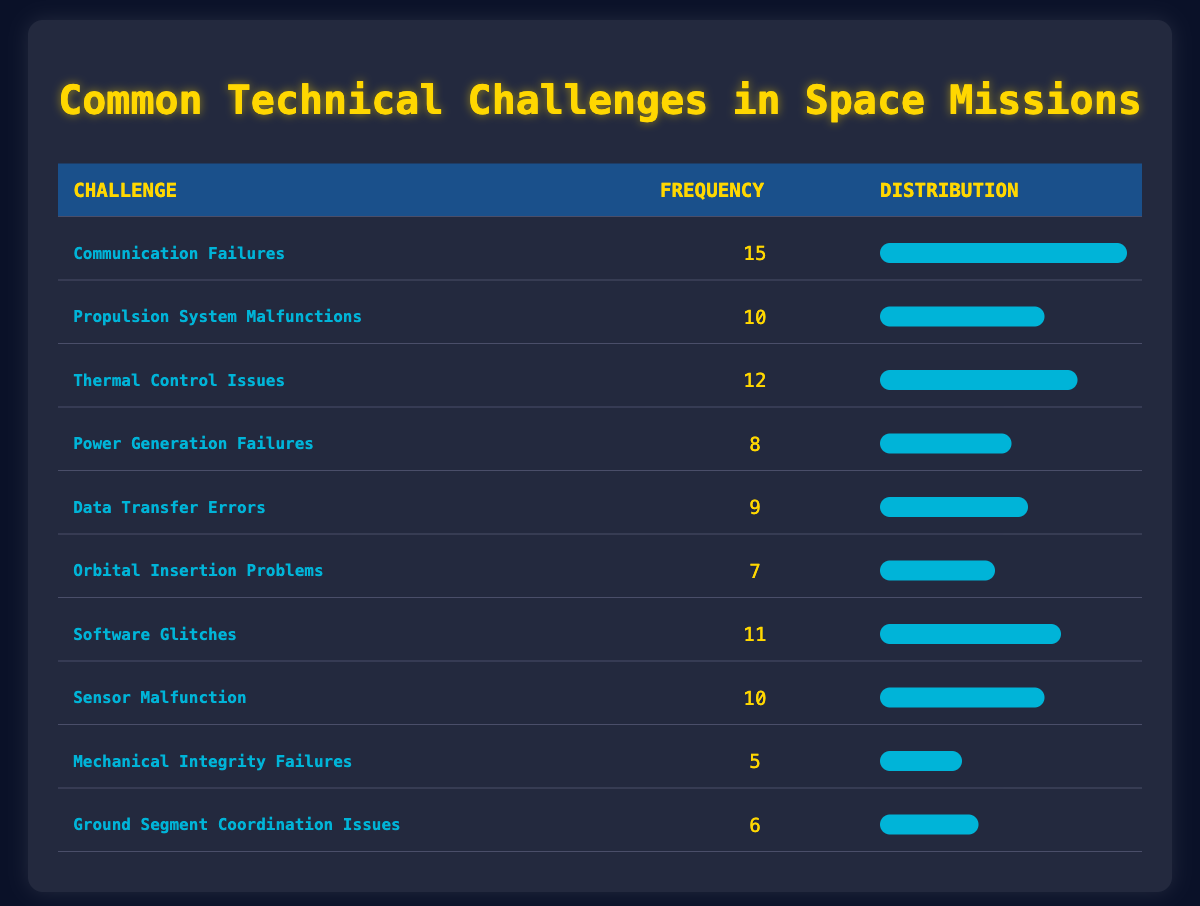What is the most common technical challenge encountered during space missions? The table shows "Communication Failures" with a frequency of 15, which is higher than all other challenges listed.
Answer: Communication Failures How many challenges have a frequency of 10 or more? The challenges with frequencies 10 or more are: Communication Failures (15), Thermal Control Issues (12), Software Glitches (11), and there are two more: Propulsion System Malfunctions and Sensor Malfunction (both with 10). In total, there are 5 challenges.
Answer: 5 Is "Ground Segment Coordination Issues" among the top three most frequent challenges? The frequencies for challenges are: 15 for Communication Failures, 12 for Thermal Control Issues, 11 for Software Glitches, and 10 for both Propulsion Malfunction and Sensor Malfunction. "Ground Segment Coordination Issues" has a frequency of 6, which is not in the top three.
Answer: No What is the total frequency of thermal control issues and propulsion system malfunctions? The frequency of Thermal Control Issues is 12 and that of Propulsion System Malfunctions is 10. Adding these gives 12 + 10 = 22.
Answer: 22 Which challenges have lower frequencies than "Power Generation Failures"? "Power Generation Failures" has a frequency of 8. The challenges lower than 8 are: Orbital Insertion Problems (7), Mechanical Integrity Failures (5), and Ground Segment Coordination Issues (6). Thus, three challenges are lower.
Answer: Orbital Insertion Problems, Mechanical Integrity Failures, Ground Segment Coordination Issues What is the difference in frequency between the most common and the least common challenges? The most common challenge, Communication Failures, has a frequency of 15. The least common, Mechanical Integrity Failures, has a frequency of 5. The difference is 15 - 5 = 10.
Answer: 10 What is the average frequency of the listed challenges? To find the average, sum all the frequencies: 15 + 10 + 12 + 8 + 9 + 7 + 11 + 10 + 5 + 6 = 88. There are 10 challenges, so dividing 88 by 10 gives an average of 8.8.
Answer: 8.8 Are there any challenges with frequencies equal to or greater than 11? The challenges with frequencies equal to or greater than 11 are: Communication Failures (15), Thermal Control Issues (12), and Software Glitches (11). Thus, there are three such challenges.
Answer: Yes 